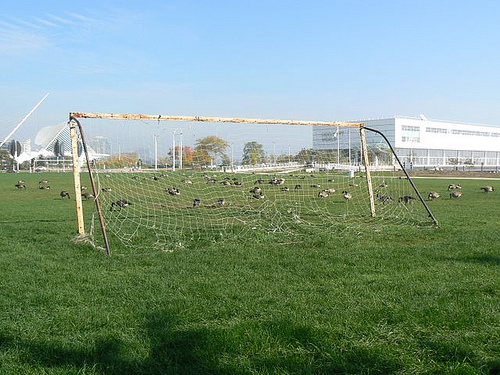<image>
Is the goose behind the goal post? Yes. From this viewpoint, the goose is positioned behind the goal post, with the goal post partially or fully occluding the goose. Where is the sky in relation to the building? Is it behind the building? Yes. From this viewpoint, the sky is positioned behind the building, with the building partially or fully occluding the sky. 